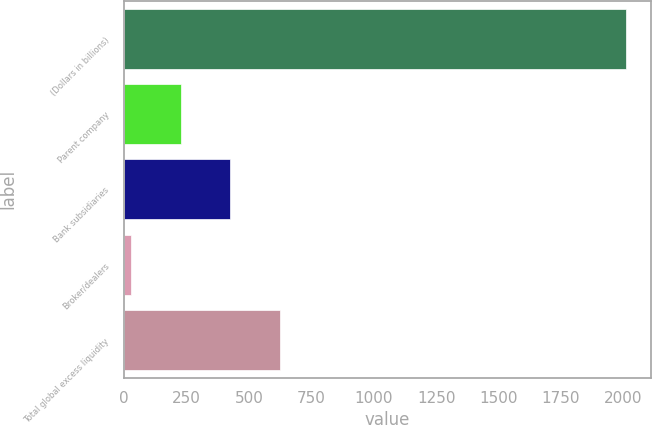<chart> <loc_0><loc_0><loc_500><loc_500><bar_chart><fcel>(Dollars in billions)<fcel>Parent company<fcel>Bank subsidiaries<fcel>Broker/dealers<fcel>Total global excess liquidity<nl><fcel>2011<fcel>227.2<fcel>425.4<fcel>29<fcel>623.6<nl></chart> 